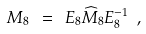<formula> <loc_0><loc_0><loc_500><loc_500>M _ { 8 } \ = \ E _ { 8 } \widehat { M } _ { 8 } E ^ { - 1 } _ { 8 } \ ,</formula> 